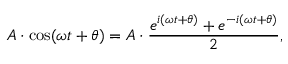Convert formula to latex. <formula><loc_0><loc_0><loc_500><loc_500>A \cdot \cos ( \omega t + \theta ) = A \cdot { \frac { e ^ { i ( \omega t + \theta ) } + e ^ { - i ( \omega t + \theta ) } } { 2 } } ,</formula> 